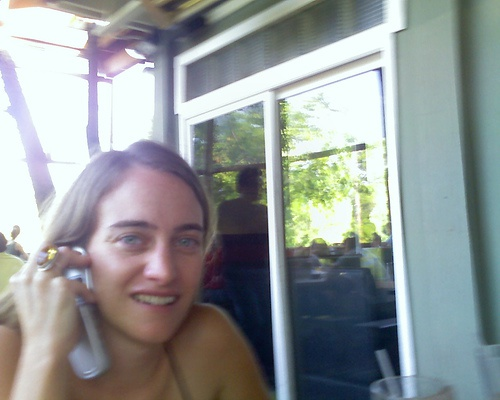Describe the objects in this image and their specific colors. I can see people in lightgray, gray, and maroon tones, people in lightgray, black, and gray tones, cell phone in lightgray and gray tones, people in lightgray, beige, khaki, and darkgray tones, and cup in lightgray, gray, and lightblue tones in this image. 